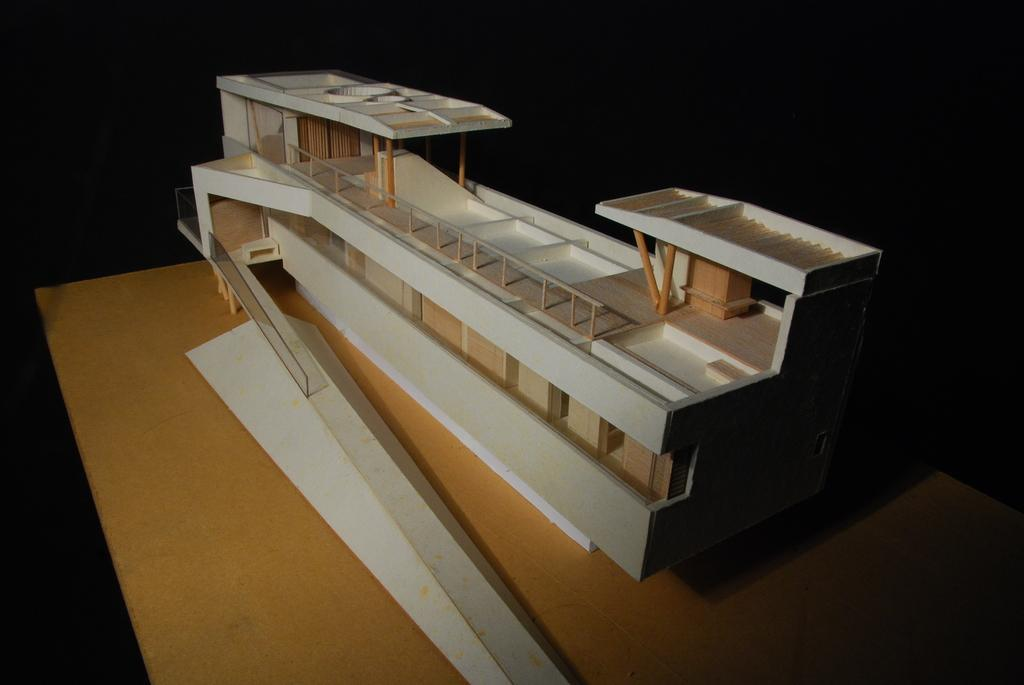What is the main subject of the image? The main subject of the image is a miniature building. Where is the miniature building located? The miniature building is on a wooden surface. How many apples are on the miniature building in the image? There are no apples present in the image. What type of pest can be seen crawling on the miniature building in the image? There are no pests visible on the miniature building in the image. 